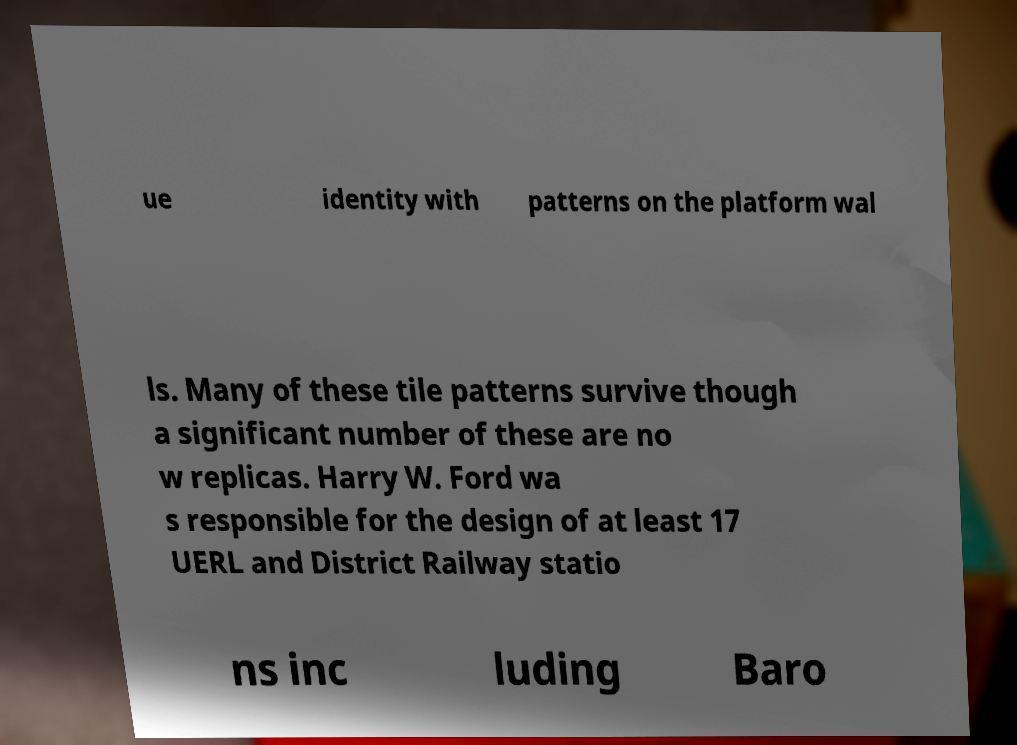Can you read and provide the text displayed in the image?This photo seems to have some interesting text. Can you extract and type it out for me? ue identity with patterns on the platform wal ls. Many of these tile patterns survive though a significant number of these are no w replicas. Harry W. Ford wa s responsible for the design of at least 17 UERL and District Railway statio ns inc luding Baro 